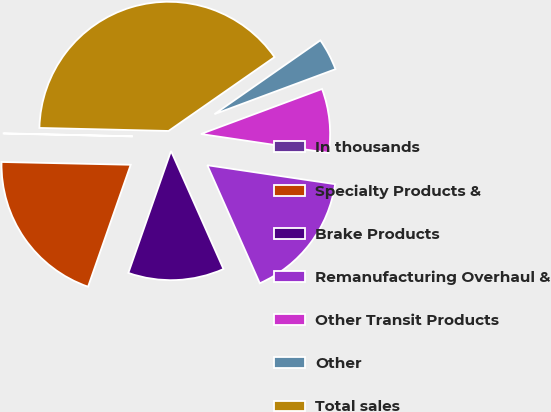<chart> <loc_0><loc_0><loc_500><loc_500><pie_chart><fcel>In thousands<fcel>Specialty Products &<fcel>Brake Products<fcel>Remanufacturing Overhaul &<fcel>Other Transit Products<fcel>Other<fcel>Total sales<nl><fcel>0.03%<fcel>19.99%<fcel>12.01%<fcel>16.0%<fcel>8.01%<fcel>4.02%<fcel>39.94%<nl></chart> 